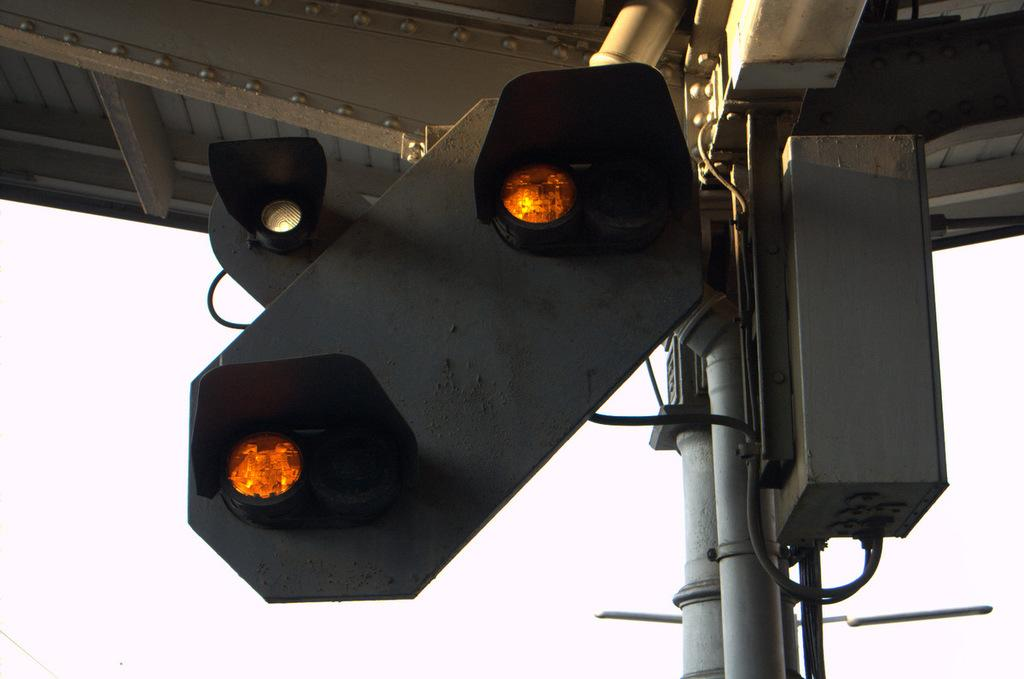What is attached to the poles in the image? Signal lights are attached to poles in the image. What is above the signal lights? There is a roof above the signal lights. What color is the background of the image? The background of the image is white in color. How does the jellyfish interact with the signal lights in the image? There are no jellyfish present in the image, so it is not possible to determine how they might interact with the signal lights. 